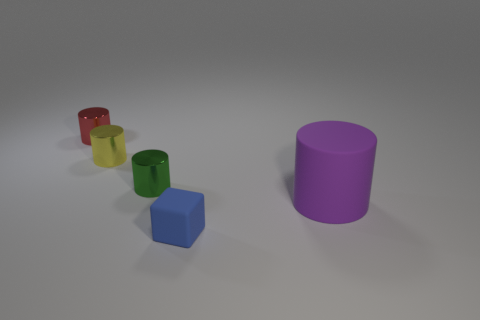There is a purple thing that is the same shape as the green object; what is it made of?
Give a very brief answer. Rubber. Are there any matte things left of the matte thing behind the tiny blue cube?
Provide a succinct answer. Yes. Do the yellow metallic thing and the tiny green object have the same shape?
Provide a succinct answer. Yes. The object that is the same material as the big cylinder is what shape?
Provide a short and direct response. Cube. Is the size of the matte thing to the left of the purple matte object the same as the cylinder that is to the left of the small yellow thing?
Give a very brief answer. Yes. Are there more tiny objects in front of the small red metallic cylinder than metallic objects that are in front of the yellow shiny thing?
Ensure brevity in your answer.  Yes. How many other things are there of the same color as the block?
Give a very brief answer. 0. There is a big thing; is it the same color as the matte thing that is in front of the big object?
Provide a succinct answer. No. There is a object that is left of the tiny yellow object; how many matte cylinders are in front of it?
Your response must be concise. 1. What is the material of the object that is in front of the rubber object that is behind the rubber object that is to the left of the big thing?
Your response must be concise. Rubber. 